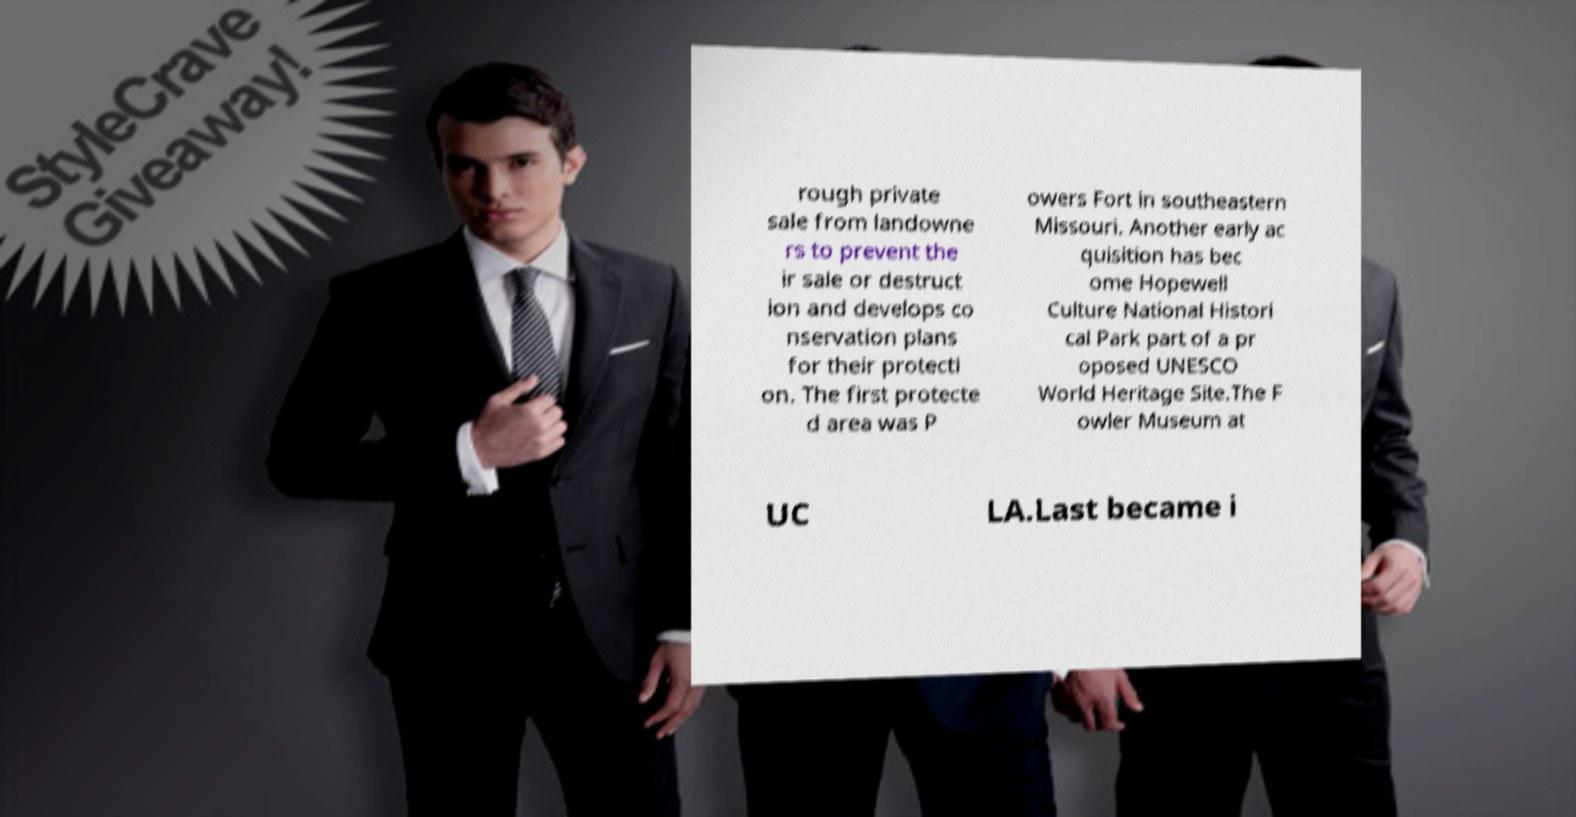Could you extract and type out the text from this image? rough private sale from landowne rs to prevent the ir sale or destruct ion and develops co nservation plans for their protecti on. The first protecte d area was P owers Fort in southeastern Missouri. Another early ac quisition has bec ome Hopewell Culture National Histori cal Park part of a pr oposed UNESCO World Heritage Site.The F owler Museum at UC LA.Last became i 